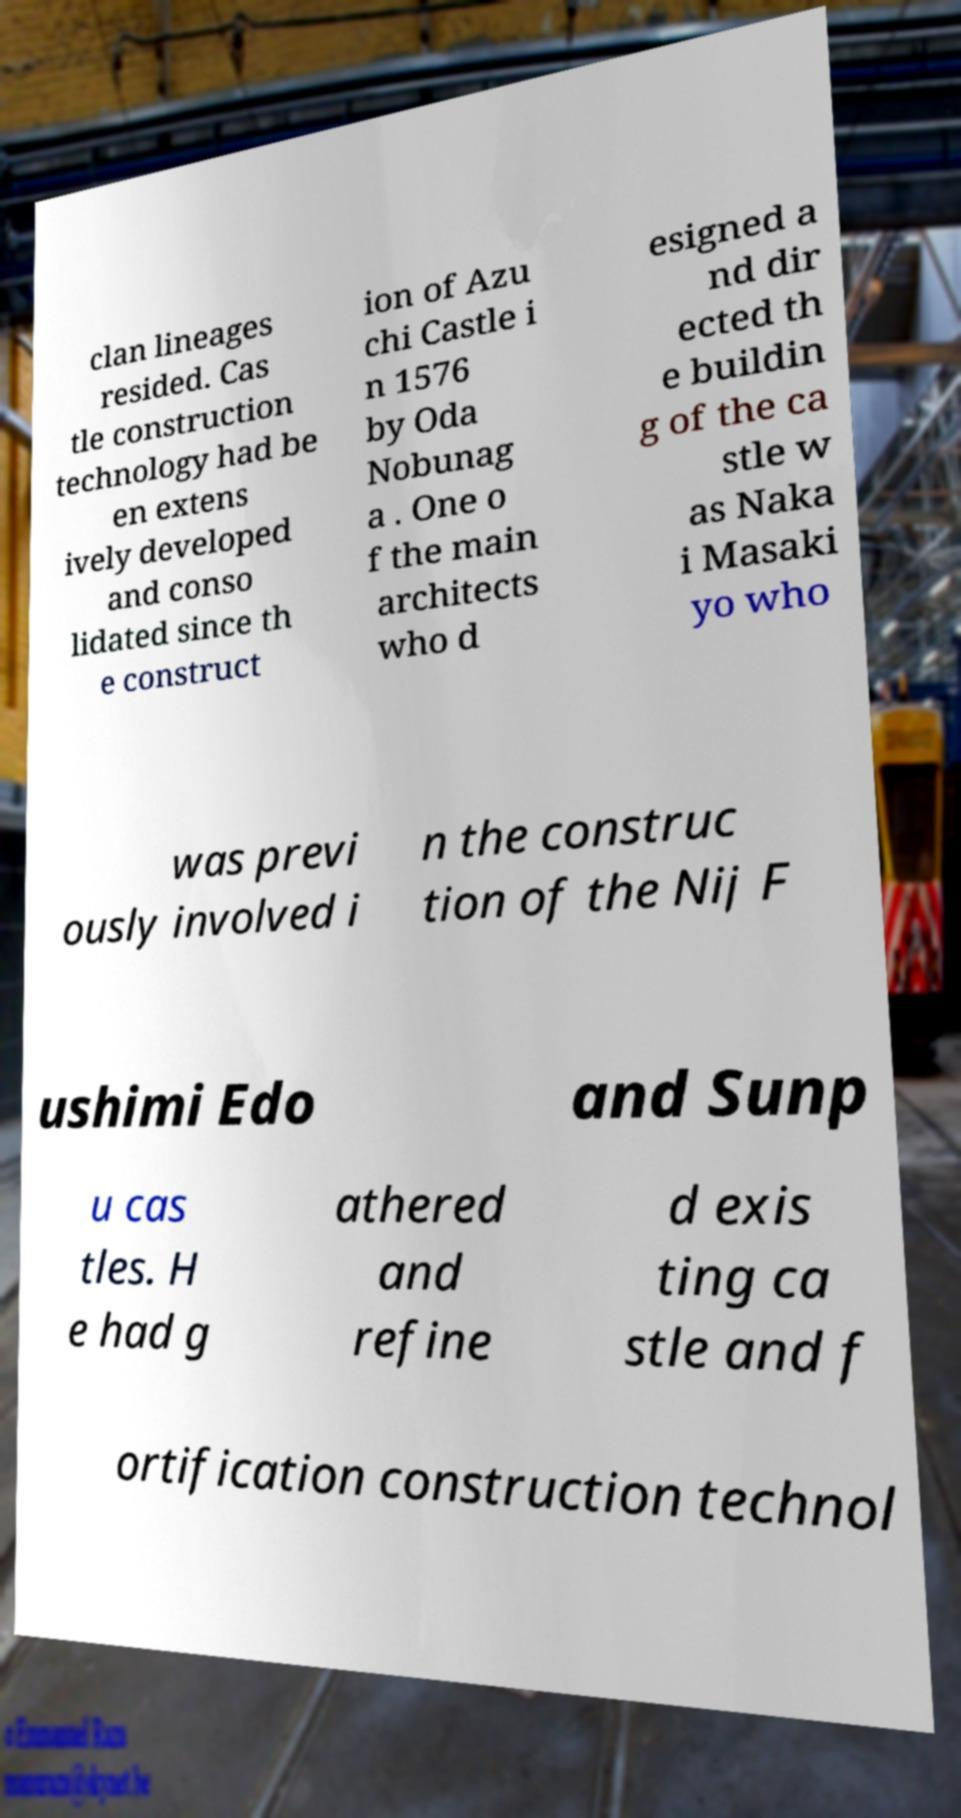Could you extract and type out the text from this image? clan lineages resided. Cas tle construction technology had be en extens ively developed and conso lidated since th e construct ion of Azu chi Castle i n 1576 by Oda Nobunag a . One o f the main architects who d esigned a nd dir ected th e buildin g of the ca stle w as Naka i Masaki yo who was previ ously involved i n the construc tion of the Nij F ushimi Edo and Sunp u cas tles. H e had g athered and refine d exis ting ca stle and f ortification construction technol 